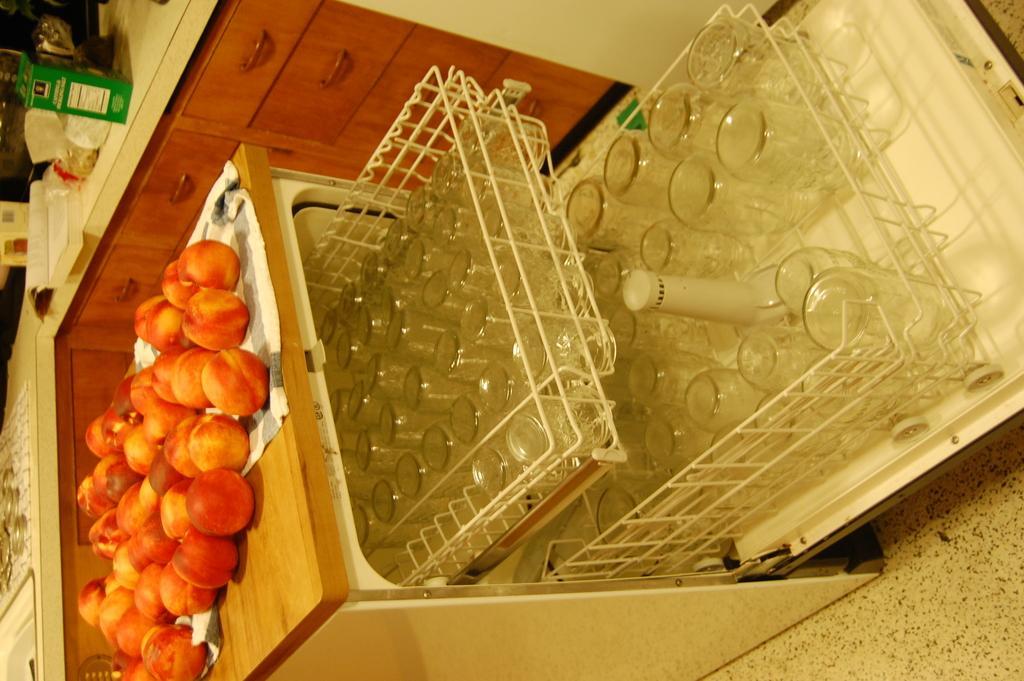Describe this image in one or two sentences. In this picture, we see the fruits are placed on a table. In the middle, we see the cupboard drawers in which the glasses are placed. Beside that, we see the drawers. We see a counter top or a table on which a book, green color box, and white color objects are placed. 